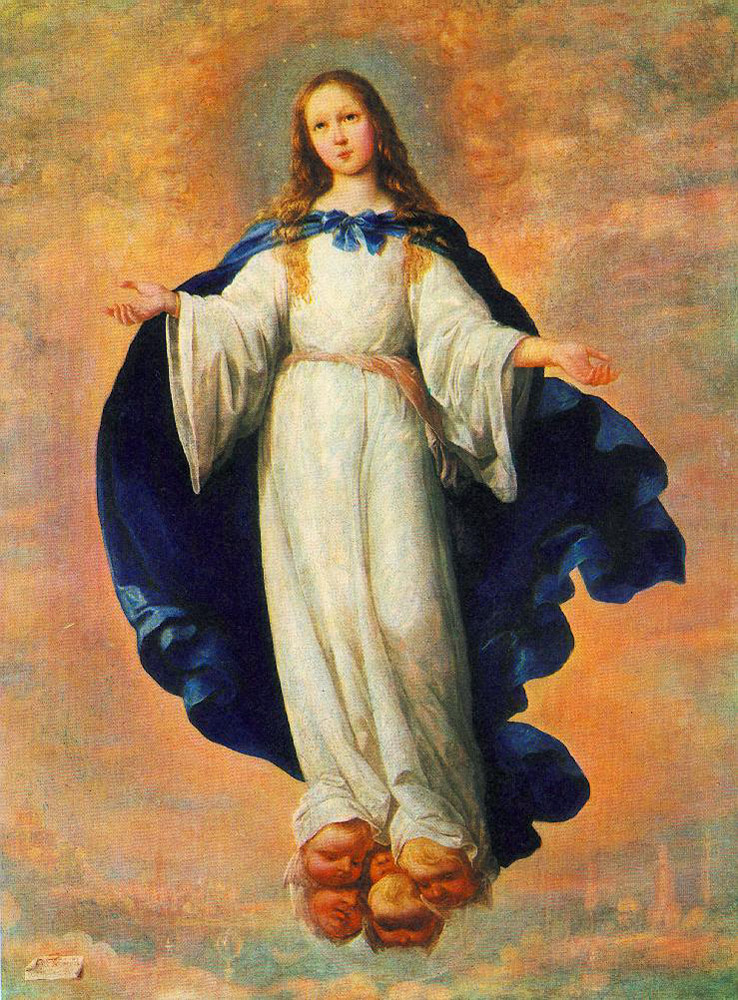What's your first impression of this artwork? This artwork immediately conveys a sense of serenity and divinity. The gracefully floating figure, paired with the ethereal, luminous background, evokes an otherworldly experience. It feels like a moment captured from a sacred vision, with the young girl embodying an angelic or divine presence. Can you describe the atmosphere created by the background? The background exudes a celestial atmosphere with its soft, glowing clouds and warm hues, ranging from gentle blues to radiant golds. This creates a divine, almost heavenly ambiance that not only enhances the subject’s ethereal appearance but also makes the setting feel otherworldly and serene. The faded cityscape below adds a layer of depth, juxtaposing the earthly with the divine. What could be the significance of the cityscape beneath the clouds? The cityscape beneath the clouds may symbolize the connection between the divine and the earthly realms. It serves as a reminder that while the divine figure floats in a heavenly realm, it remains connected to the human world below. This duality could reflect themes of protection, guidance, or the ever-present influence of the divine in everyday life. Imagine this figure descends to the city. What might happen next? If this figure were to descend gracefully from the skies to the city below, it could be an awe-inspiring event for the inhabitants. People might gather in astonishment, thinking a divine being has come to guide or aide them. This miraculous visitation could spark a transformation within the city, fostering hope, unity, and renewed spiritual faith among its citizens. There might be an air of celebration and reverence, with tales of this miraculous descent being passed down through generations. What does the color palette tell us about the mood? The color palette, dominated by soft blues, radiant golds, and whites, contributes to a mood of calmness, purity, and divine radiance. The soft transitions between these colors create a soothing and harmonious visual experience, emphasizing tranquility and a celestial feel. The light and warm tones evoke feelings of peace and enlightenment, suggesting a serene and holy atmosphere. 